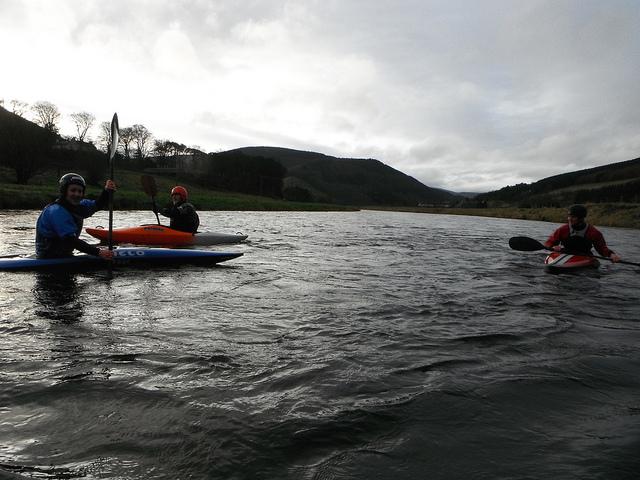What is connected to her foot?
Be succinct. Kayak. How deep is the water?
Quick response, please. Waist deep. Is the man in the water?
Write a very short answer. Yes. Is this person riding a board?
Concise answer only. No. Is this water cold?
Be succinct. Yes. What sport are the people engaged in?
Write a very short answer. Kayaking. What is the man teaching the boy?
Write a very short answer. Kayaking. What is the person riding?
Concise answer only. Kayak. Are the guys going on a canoe trip?
Quick response, please. Yes. Is this a river or ocean?
Write a very short answer. River. Does the man need to beware of sharks?
Quick response, please. No. Are they in a kayak?
Keep it brief. Yes. What is the weather like in this image?
Give a very brief answer. Cloudy. What is this person doing?
Short answer required. Kayaking. What is the boy sitting on?
Answer briefly. Kayak. Is this nice weather?
Answer briefly. No. What is she standing beside?
Write a very short answer. Kayak. How many people are wearing hats?
Concise answer only. 3. What are these people doing?
Answer briefly. Kayaking. What is the typical name of the thing that propels her transportation?
Concise answer only. Paddle. How many people are in the image?
Answer briefly. 3. Why are they standing in the surf?
Write a very short answer. To kayak. Will the guys get wet if they turn over?
Answer briefly. Yes. 